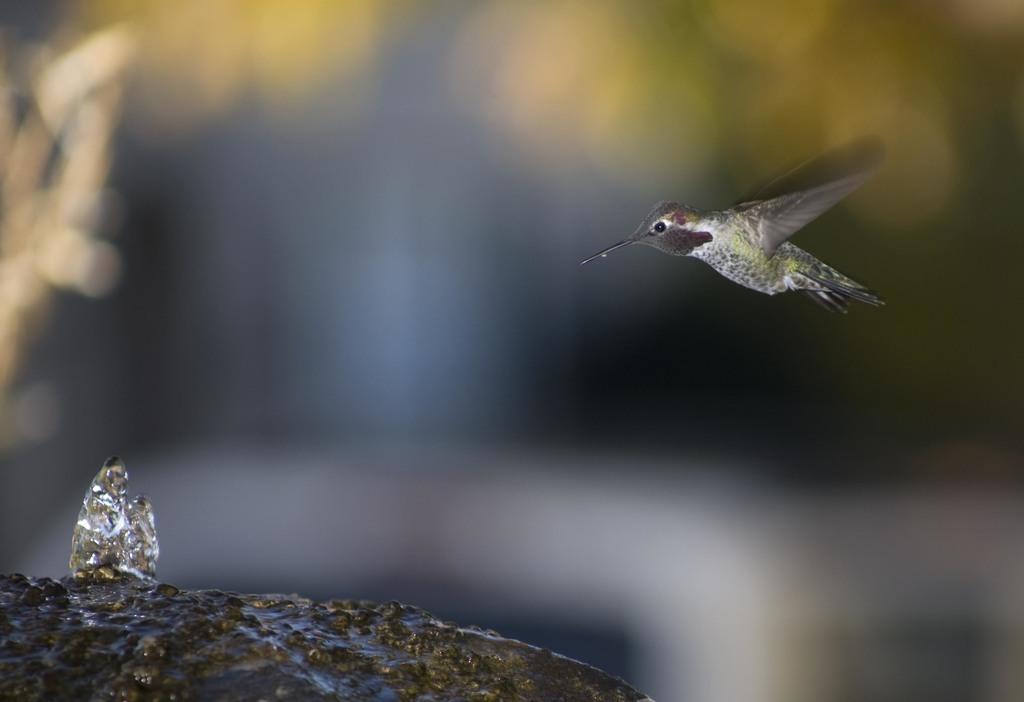What animal can be seen in the picture? There is a bird in the picture. What is the bird doing in the picture? The bird is flying towards a stone. What color is the background of the bird? The background of the bird is blue. How many oranges are being squeezed onto the toothpaste in the picture? There are no oranges or toothpaste present in the image; it features a bird flying towards a stone with a blue background. 